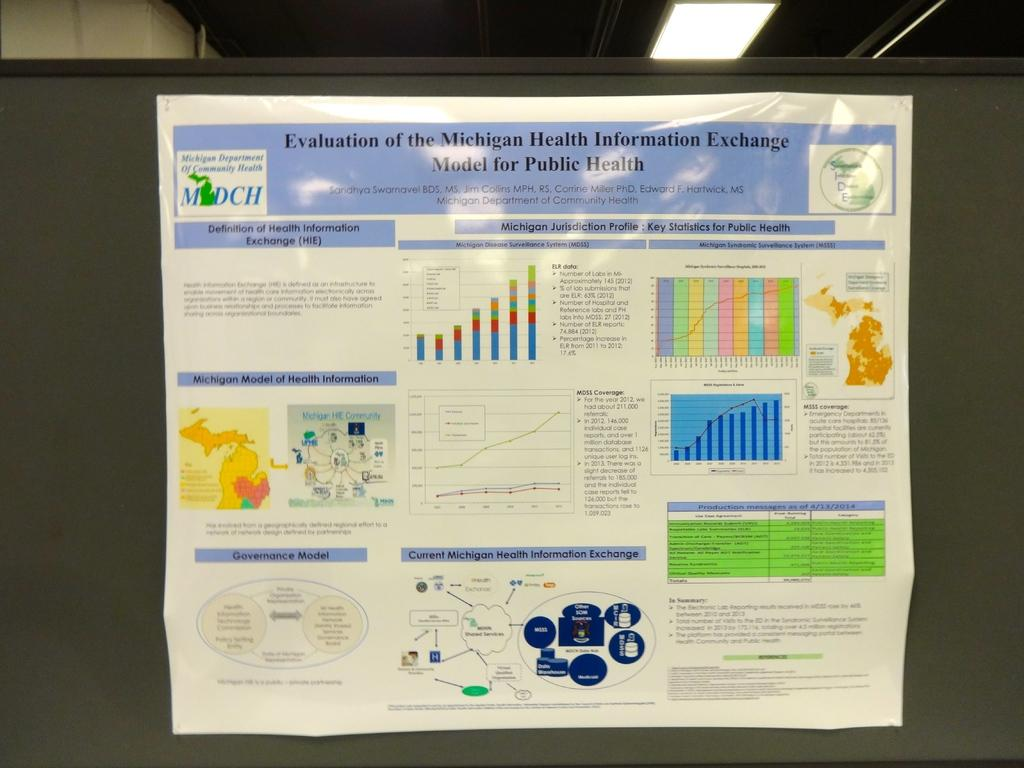<image>
Share a concise interpretation of the image provided. a flyer on a wall that says 'evaluation of the michigan health information exchange model for public health' 